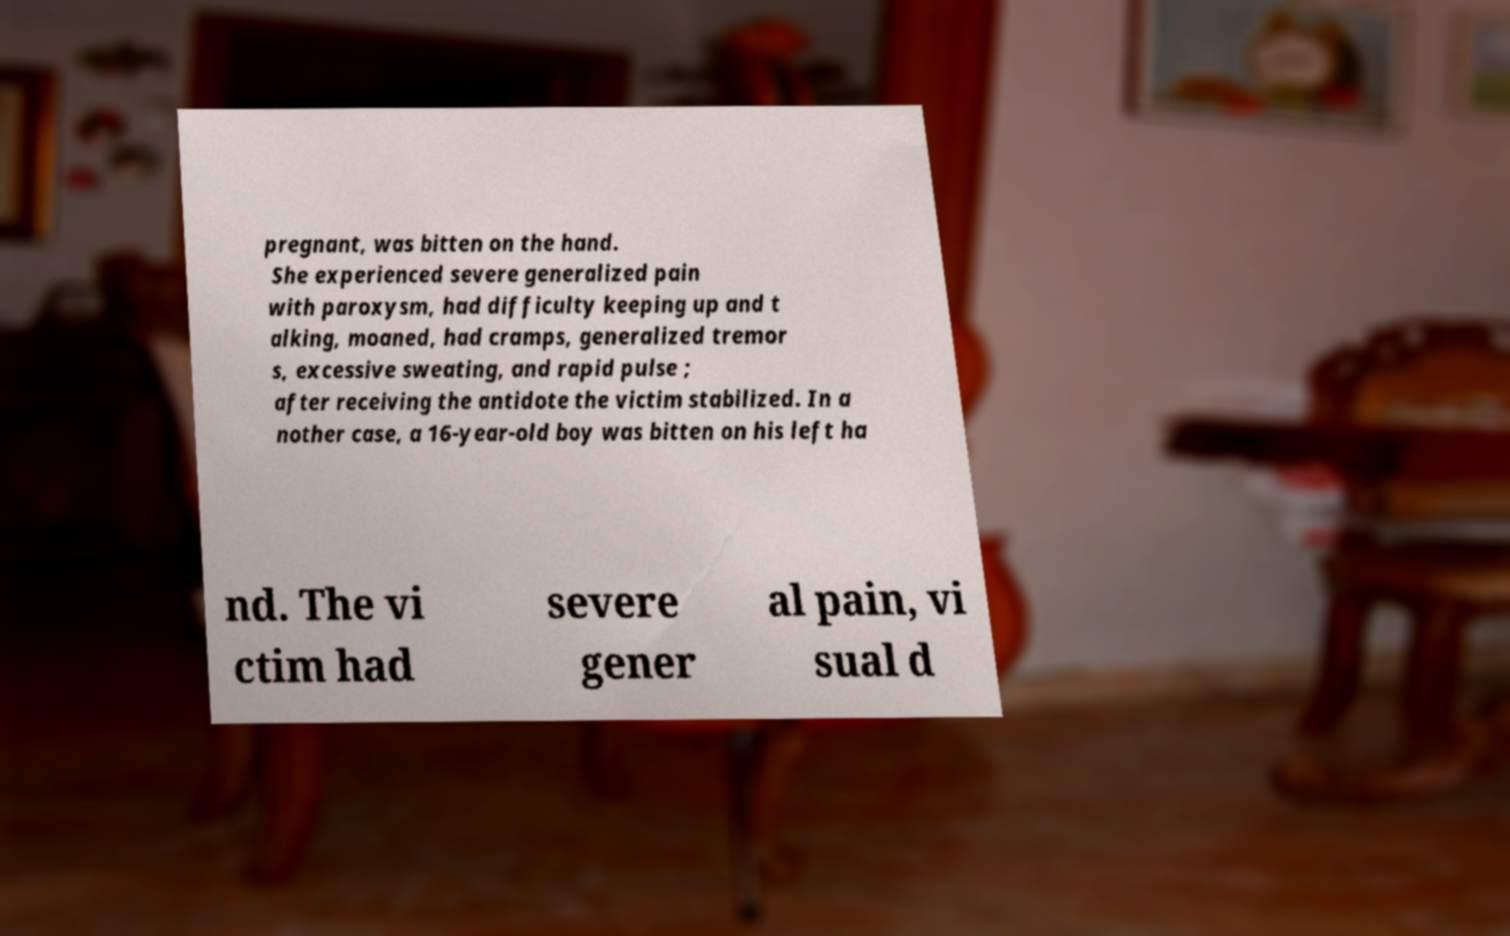Can you accurately transcribe the text from the provided image for me? pregnant, was bitten on the hand. She experienced severe generalized pain with paroxysm, had difficulty keeping up and t alking, moaned, had cramps, generalized tremor s, excessive sweating, and rapid pulse ; after receiving the antidote the victim stabilized. In a nother case, a 16-year-old boy was bitten on his left ha nd. The vi ctim had severe gener al pain, vi sual d 